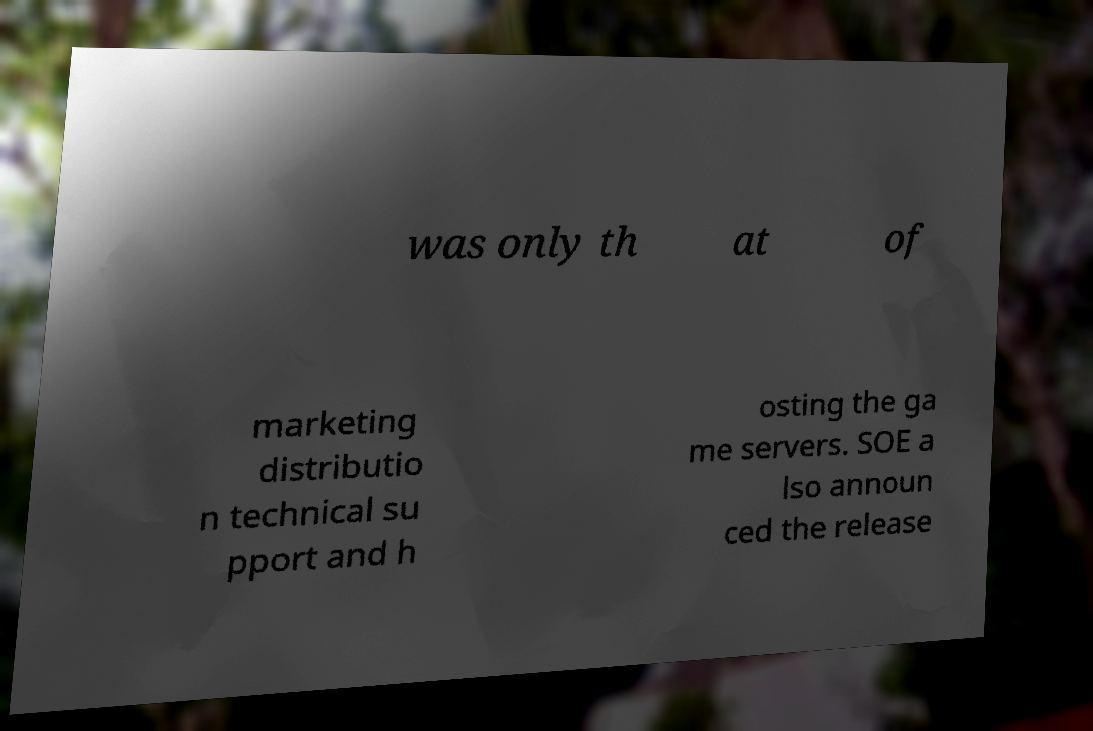There's text embedded in this image that I need extracted. Can you transcribe it verbatim? was only th at of marketing distributio n technical su pport and h osting the ga me servers. SOE a lso announ ced the release 